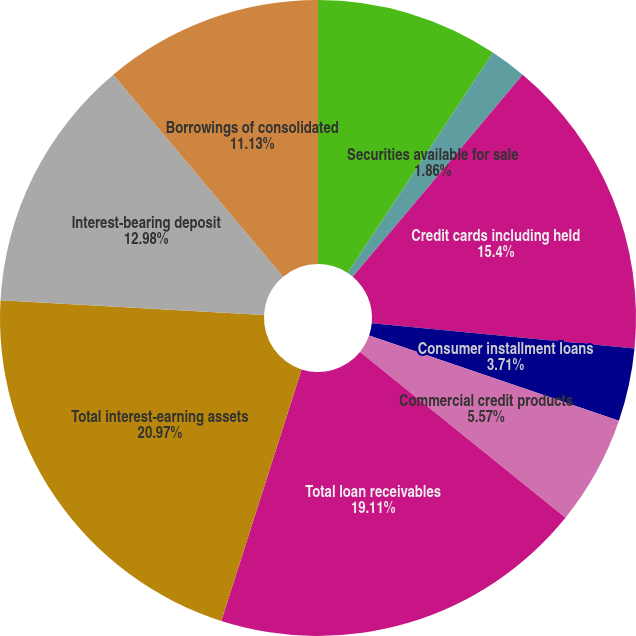Convert chart. <chart><loc_0><loc_0><loc_500><loc_500><pie_chart><fcel>Interest-earning cash and<fcel>Securities available for sale<fcel>Credit cards including held<fcel>Consumer installment loans<fcel>Commercial credit products<fcel>Other<fcel>Total loan receivables<fcel>Total interest-earning assets<fcel>Interest-bearing deposit<fcel>Borrowings of consolidated<nl><fcel>9.27%<fcel>1.86%<fcel>15.4%<fcel>3.71%<fcel>5.57%<fcel>0.0%<fcel>19.11%<fcel>20.97%<fcel>12.98%<fcel>11.13%<nl></chart> 